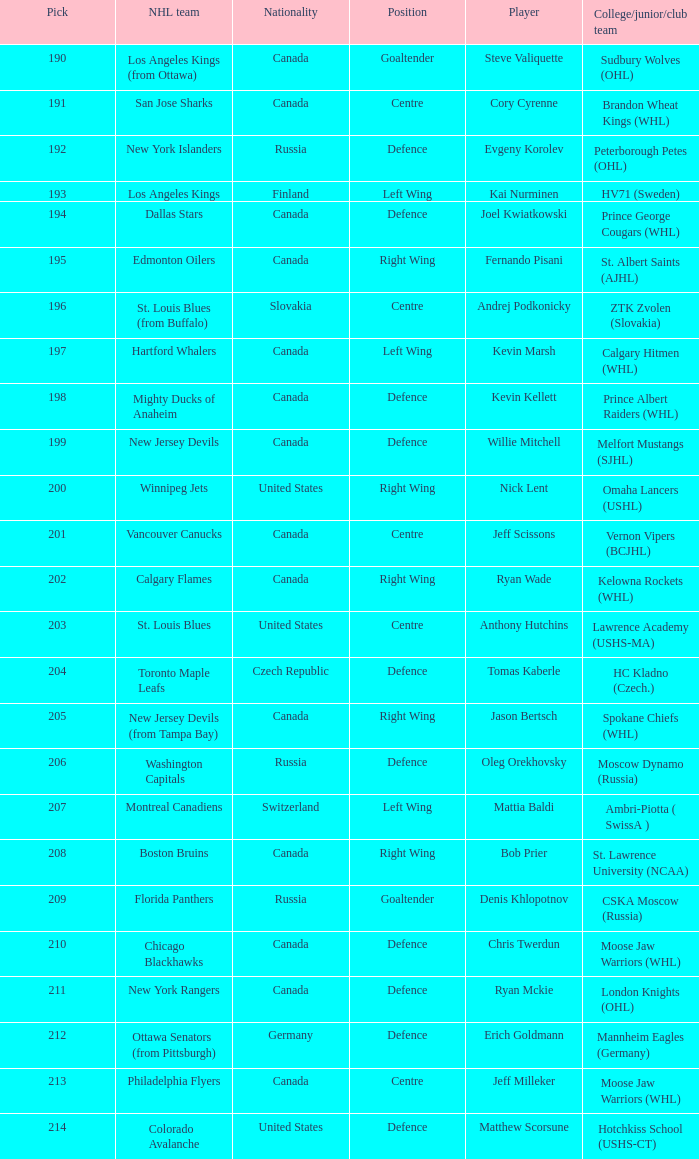Name the pick for matthew scorsune 214.0. 